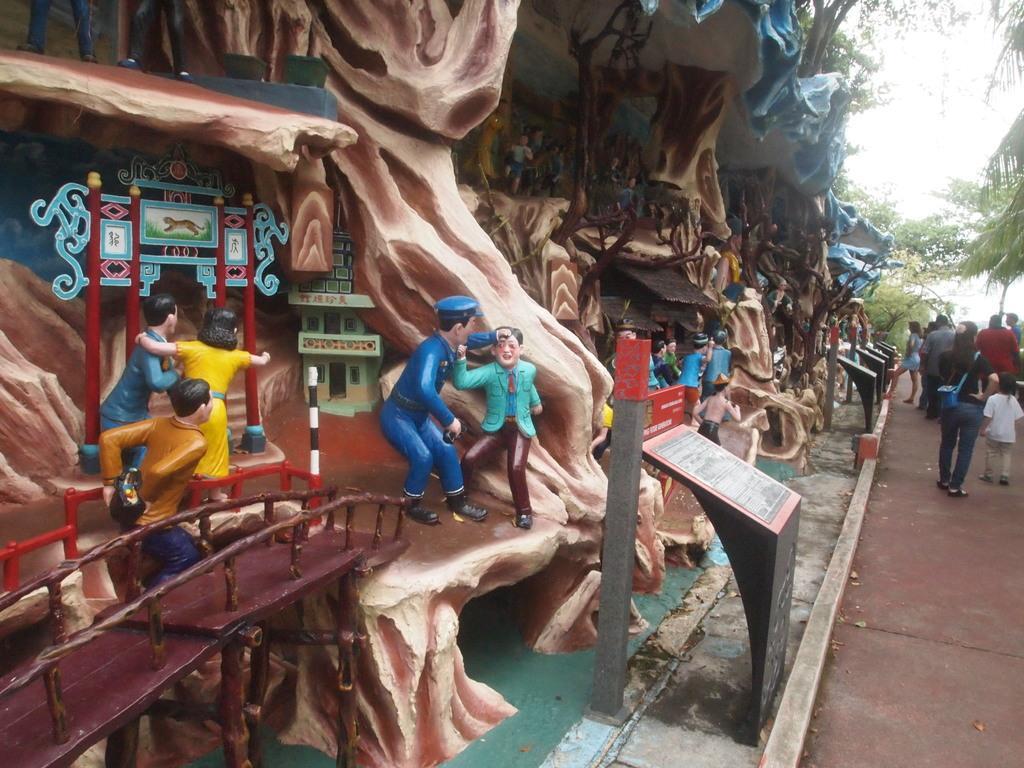Can you describe this image briefly? In this image I can see few persons statues in multi color and I can also see few people walking. In the background I can see few trees in green color and the sky is in white color. 